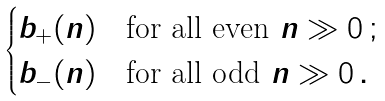Convert formula to latex. <formula><loc_0><loc_0><loc_500><loc_500>\begin{cases} b _ { + } ( n ) & \text {for all even } n \gg 0 \, ; \\ b _ { - } ( n ) & \text {for all odd } n \gg 0 \, . \end{cases}</formula> 